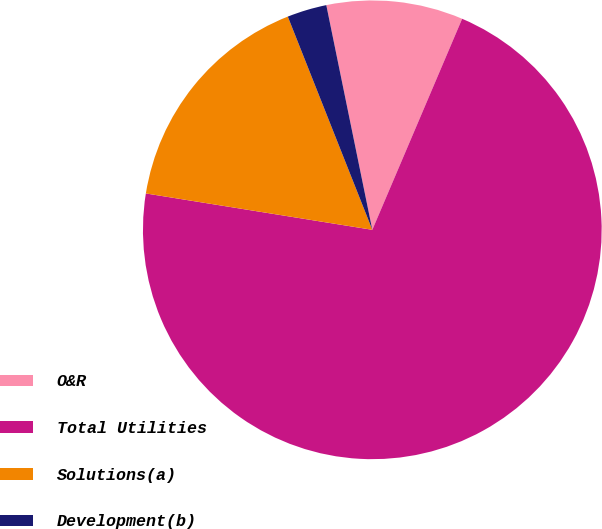Convert chart. <chart><loc_0><loc_0><loc_500><loc_500><pie_chart><fcel>O&R<fcel>Total Utilities<fcel>Solutions(a)<fcel>Development(b)<nl><fcel>9.62%<fcel>71.13%<fcel>16.46%<fcel>2.79%<nl></chart> 